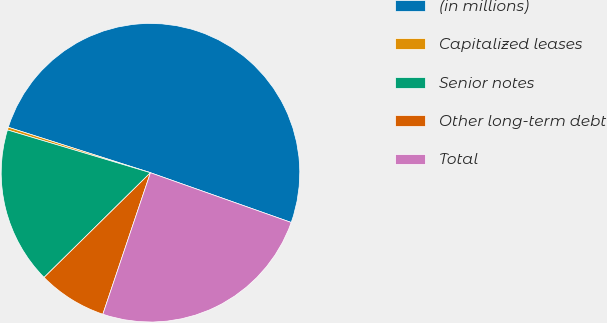Convert chart to OTSL. <chart><loc_0><loc_0><loc_500><loc_500><pie_chart><fcel>(in millions)<fcel>Capitalized leases<fcel>Senior notes<fcel>Other long-term debt<fcel>Total<nl><fcel>50.48%<fcel>0.3%<fcel>17.0%<fcel>7.46%<fcel>24.76%<nl></chart> 